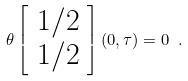<formula> <loc_0><loc_0><loc_500><loc_500>\theta \left [ \begin{array} { c } 1 / 2 \\ 1 / 2 \end{array} \right ] ( 0 , \tau ) = 0 \ .</formula> 